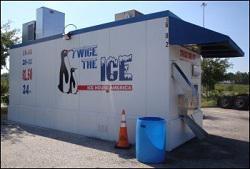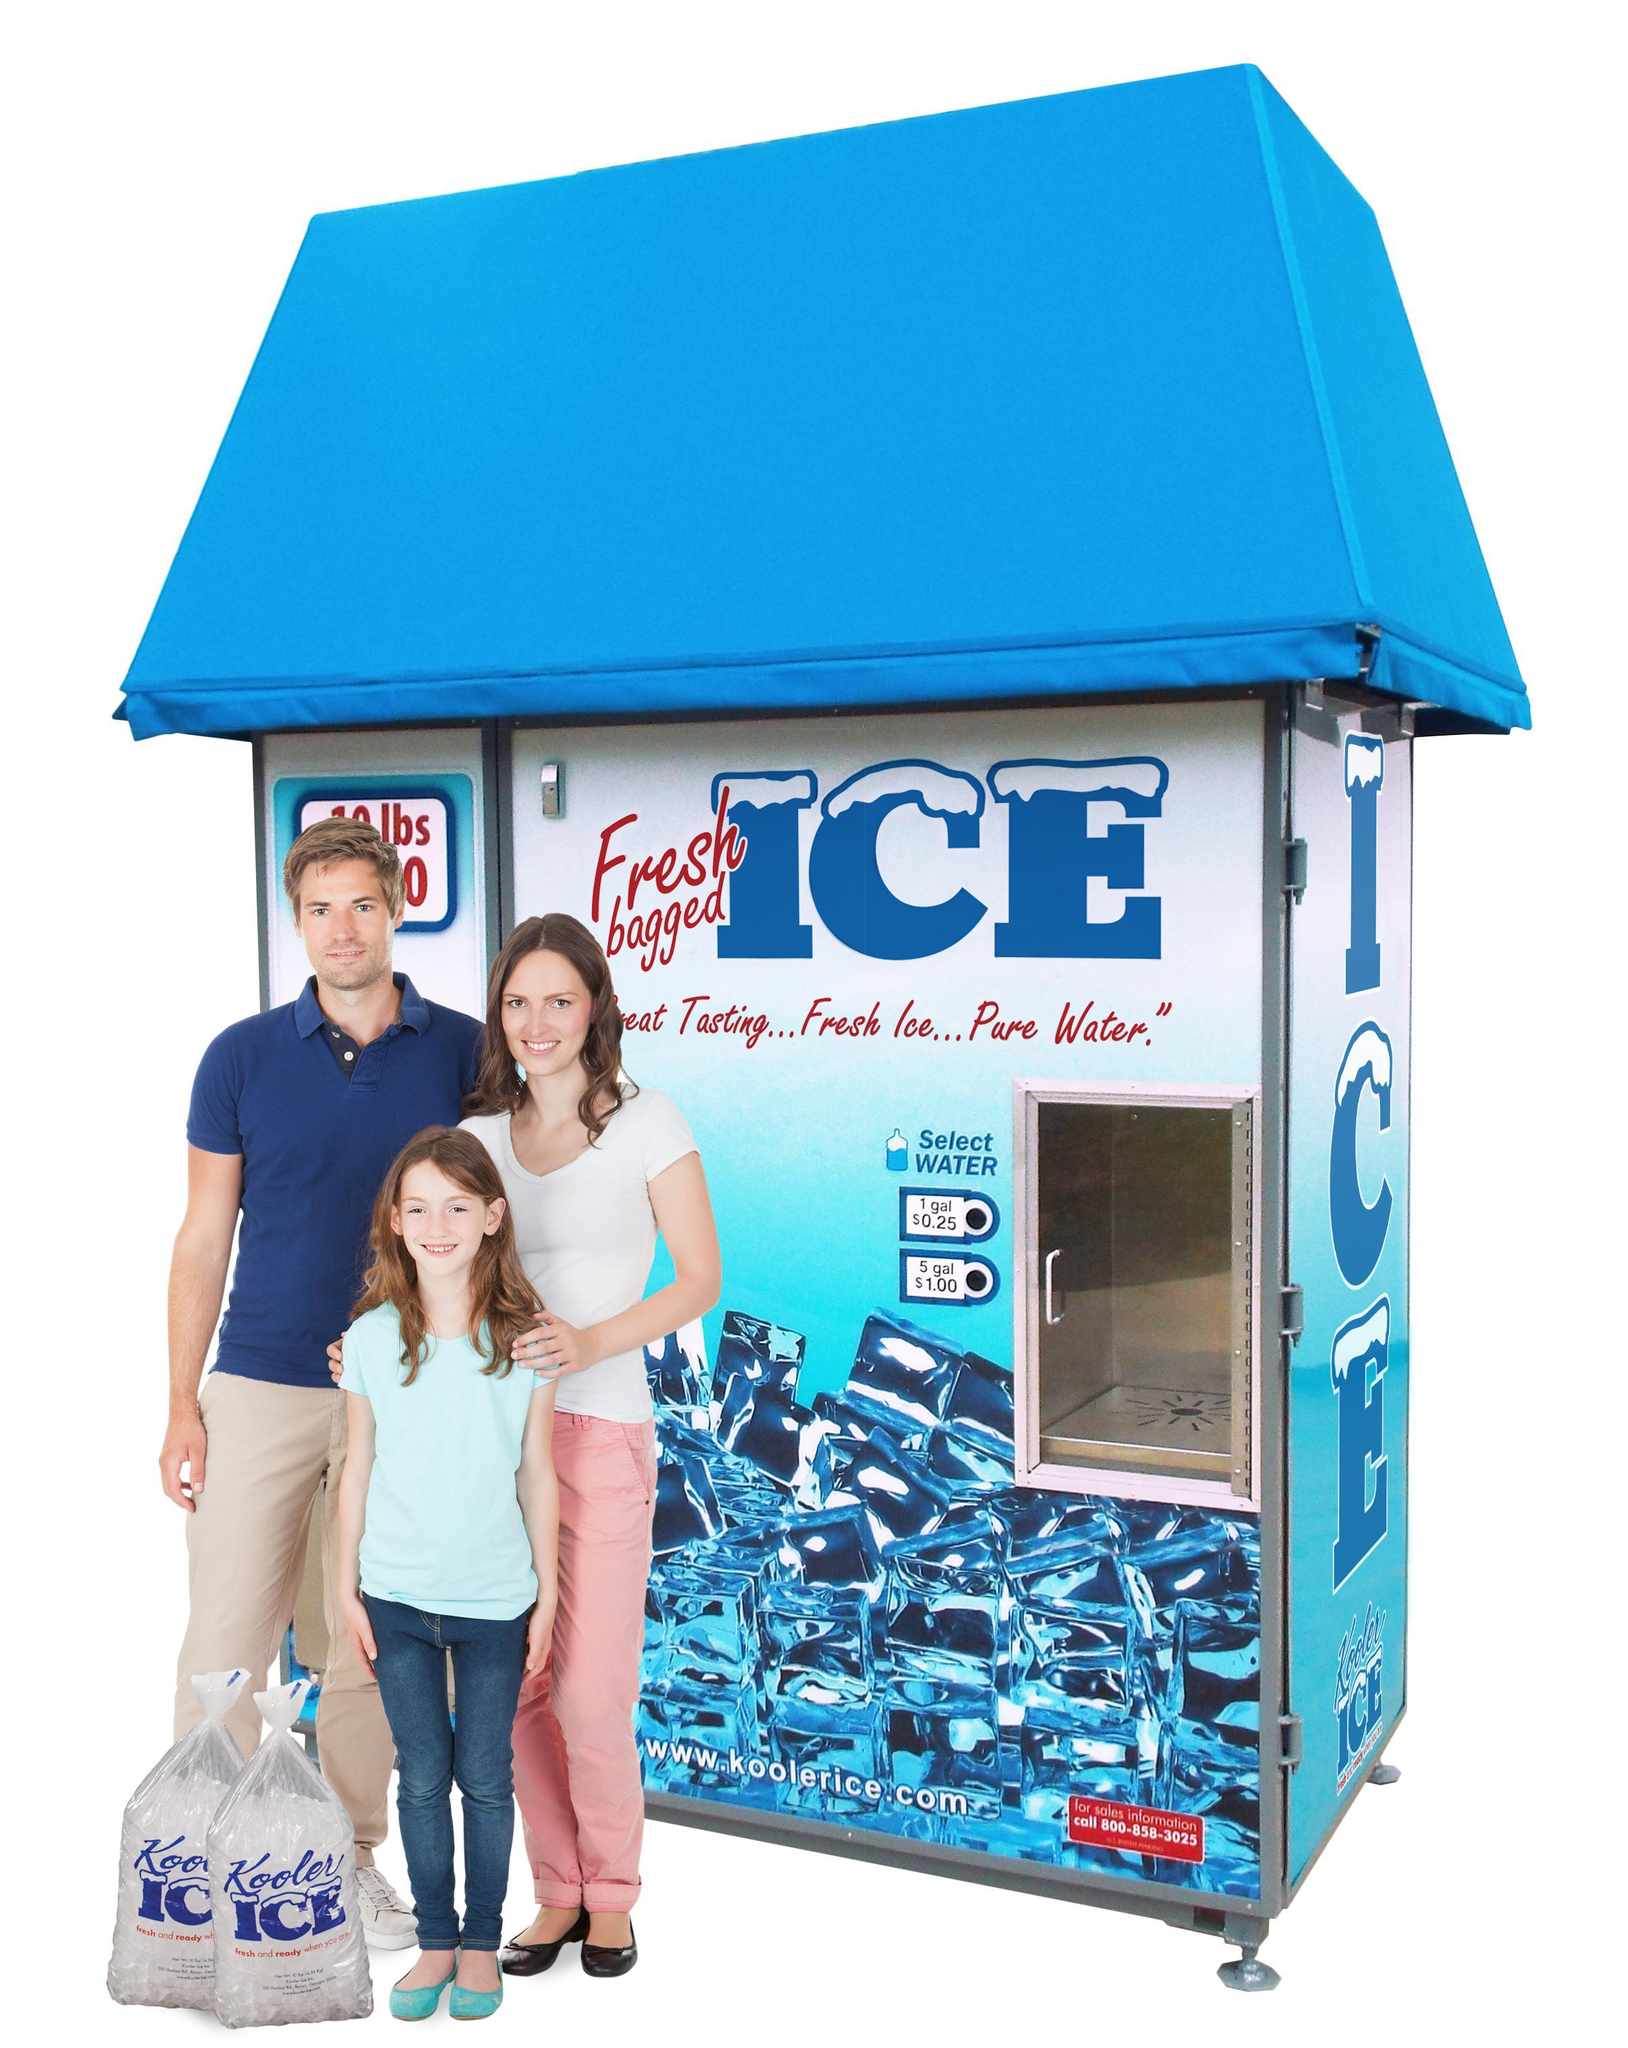The first image is the image on the left, the second image is the image on the right. For the images displayed, is the sentence "There are at least two painted penguins on the side of a ice house with blue trim." factually correct? Answer yes or no. Yes. The first image is the image on the left, the second image is the image on the right. Given the left and right images, does the statement "A person is standing in front of one of the ice machines." hold true? Answer yes or no. Yes. 